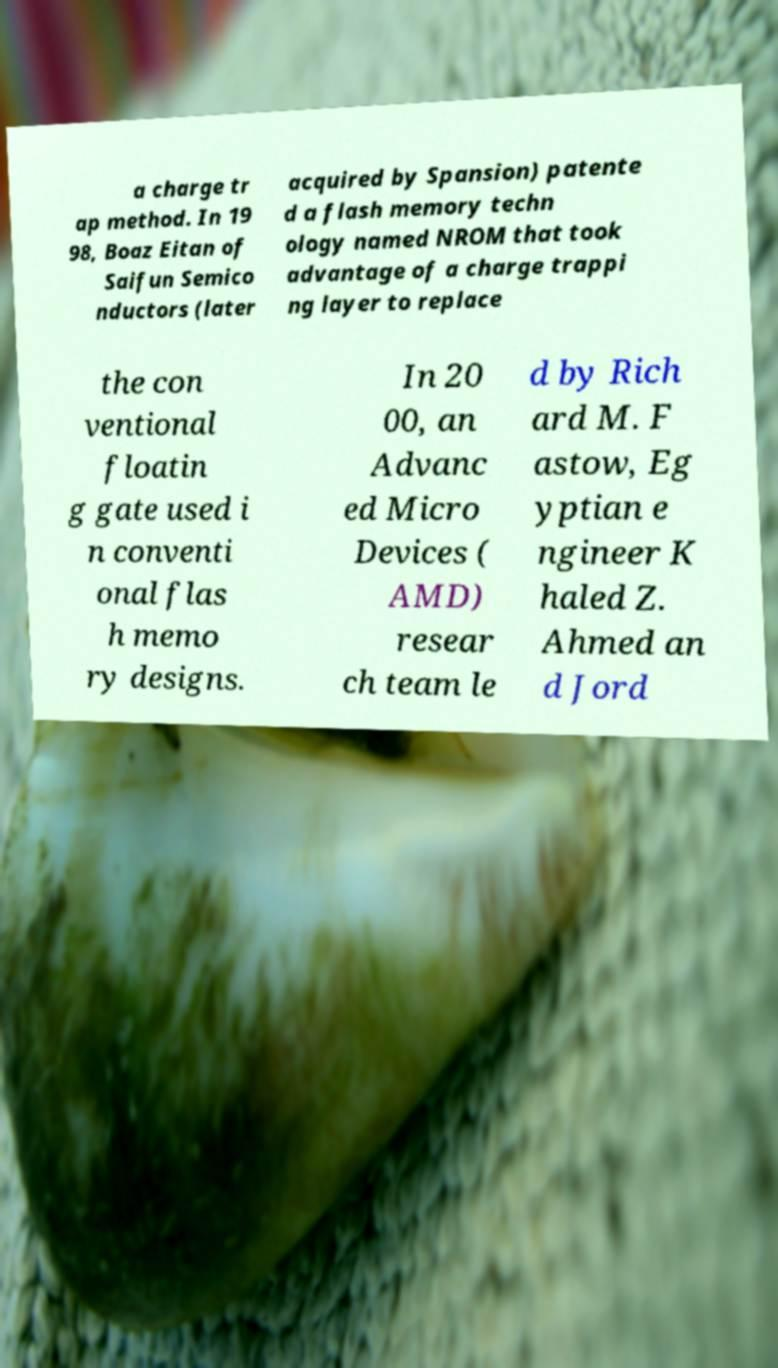Could you extract and type out the text from this image? a charge tr ap method. In 19 98, Boaz Eitan of Saifun Semico nductors (later acquired by Spansion) patente d a flash memory techn ology named NROM that took advantage of a charge trappi ng layer to replace the con ventional floatin g gate used i n conventi onal flas h memo ry designs. In 20 00, an Advanc ed Micro Devices ( AMD) resear ch team le d by Rich ard M. F astow, Eg yptian e ngineer K haled Z. Ahmed an d Jord 